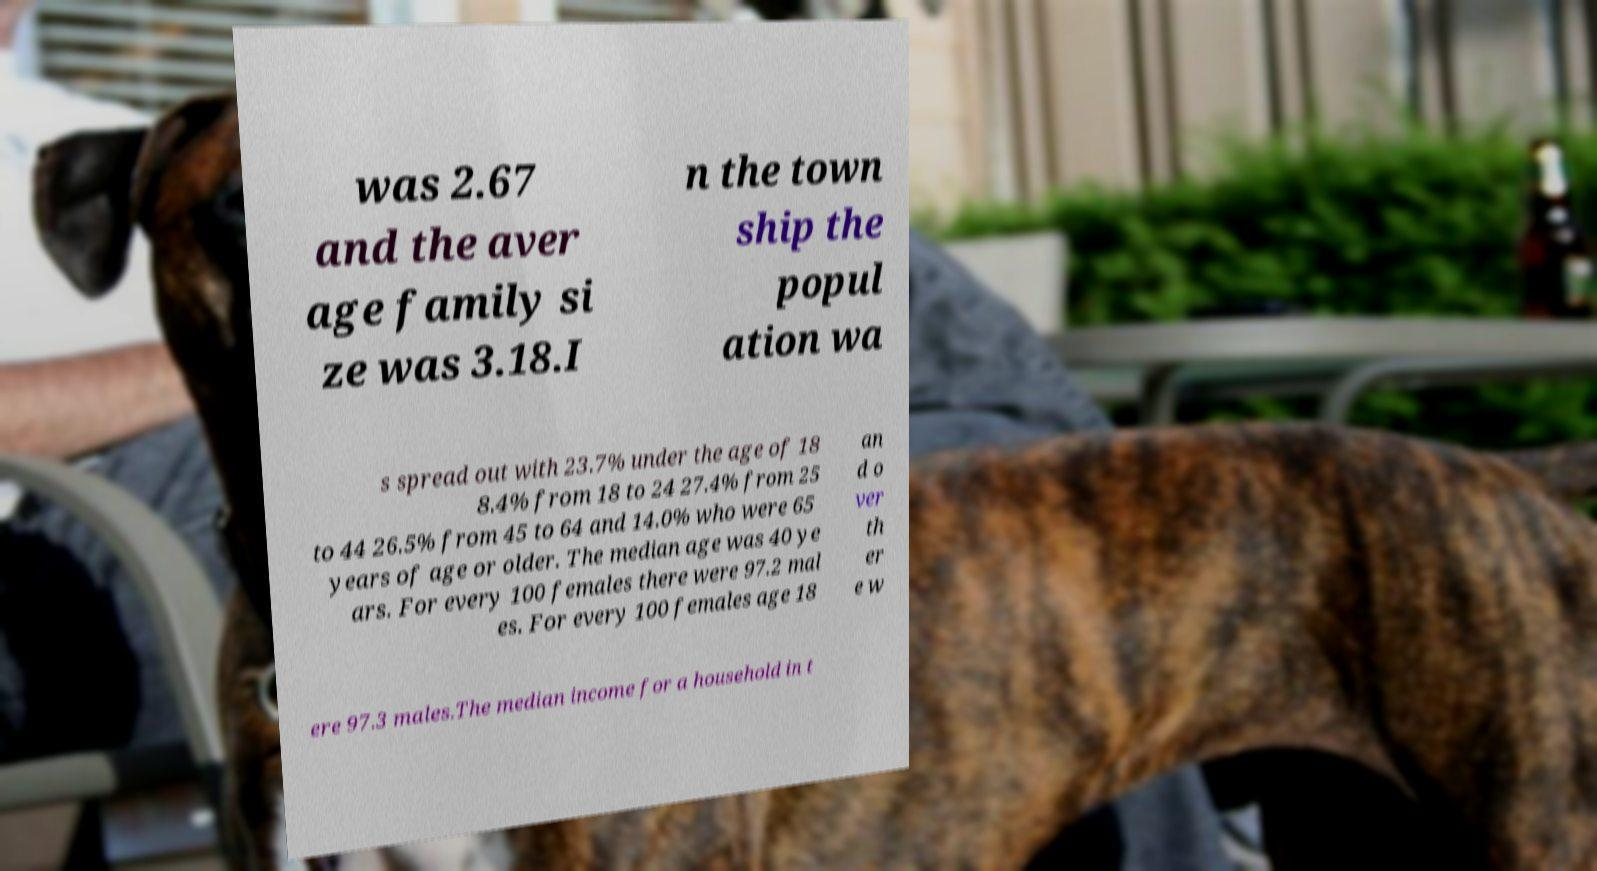What messages or text are displayed in this image? I need them in a readable, typed format. was 2.67 and the aver age family si ze was 3.18.I n the town ship the popul ation wa s spread out with 23.7% under the age of 18 8.4% from 18 to 24 27.4% from 25 to 44 26.5% from 45 to 64 and 14.0% who were 65 years of age or older. The median age was 40 ye ars. For every 100 females there were 97.2 mal es. For every 100 females age 18 an d o ver th er e w ere 97.3 males.The median income for a household in t 